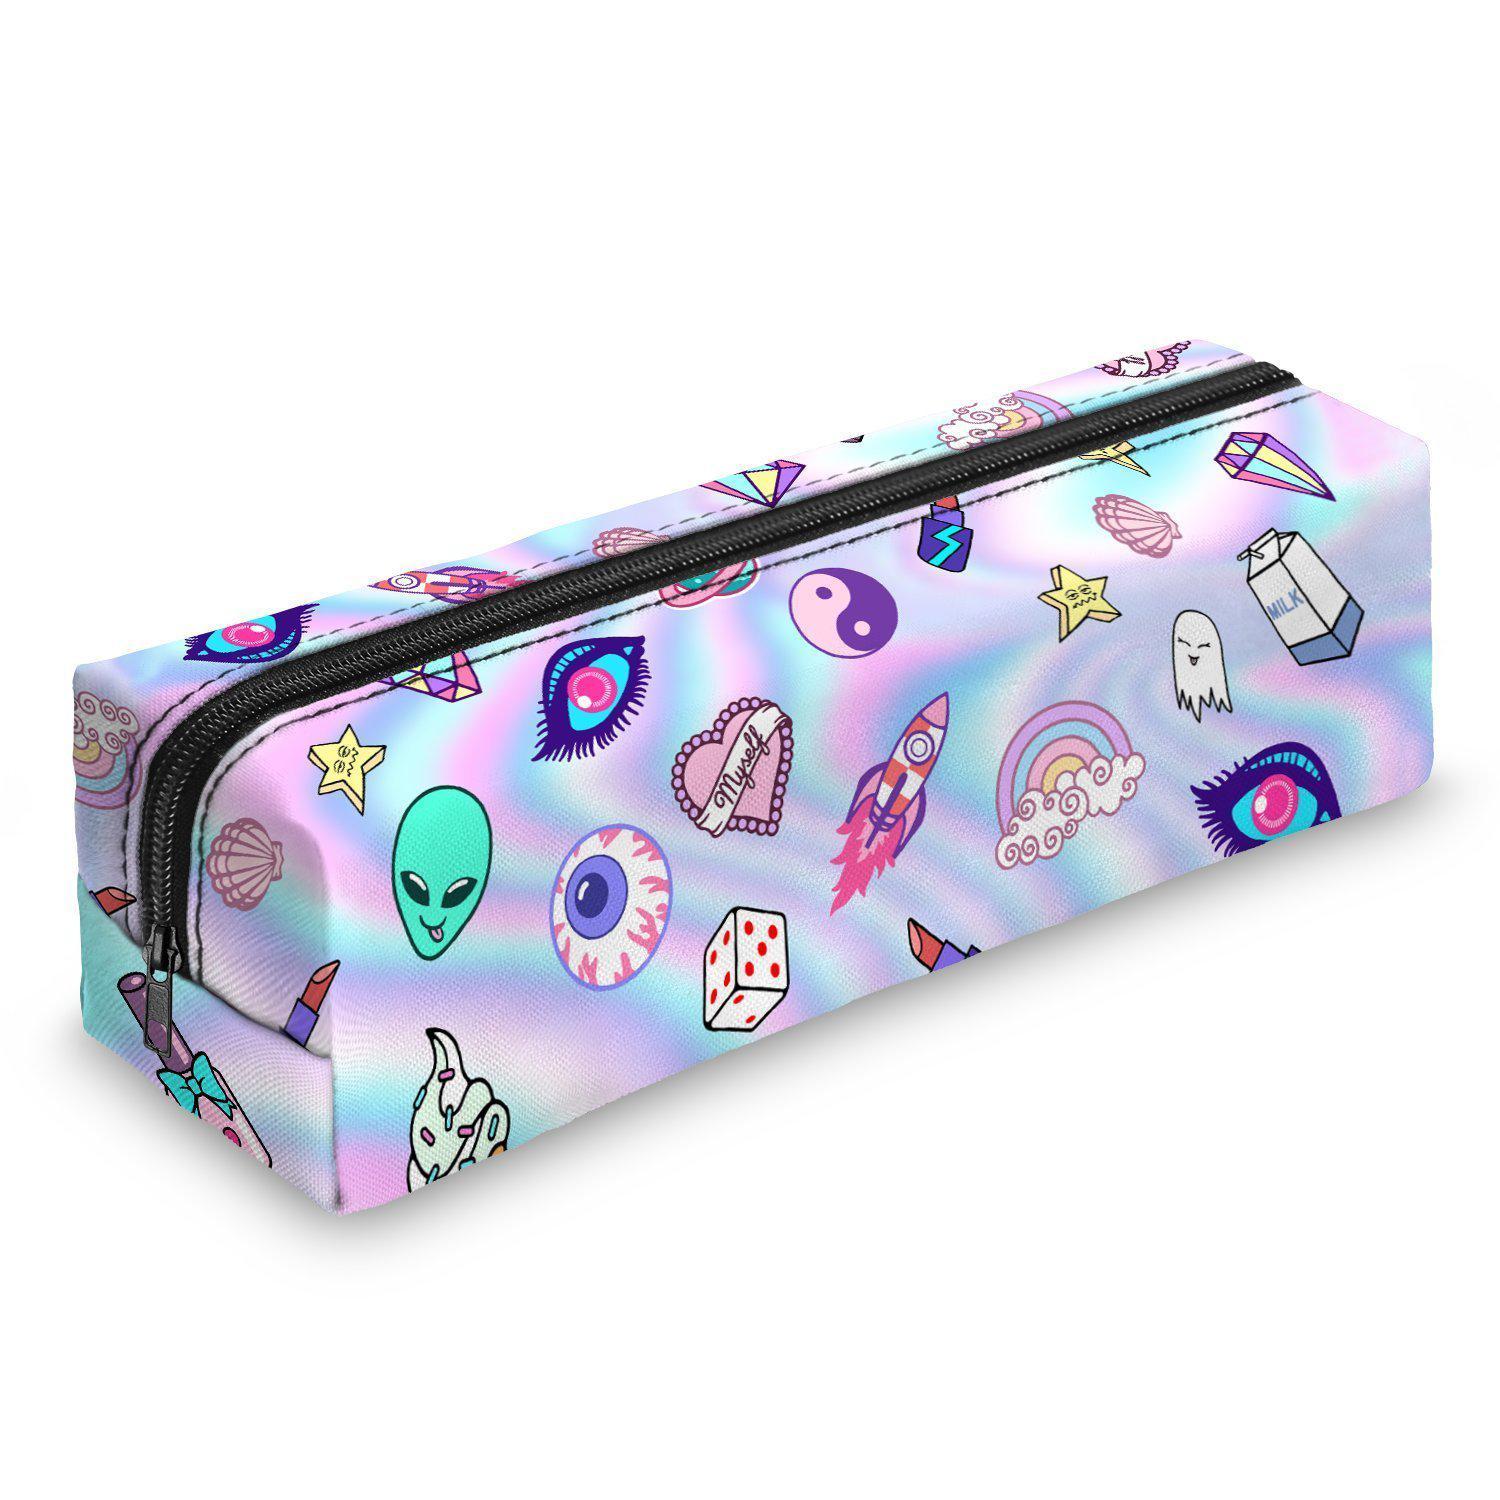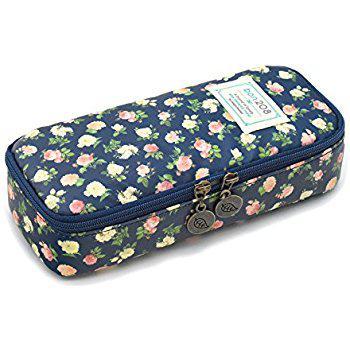The first image is the image on the left, the second image is the image on the right. Evaluate the accuracy of this statement regarding the images: "Four different variations of a pencil case, all of them closed, are depicted in one image.". Is it true? Answer yes or no. No. The first image is the image on the left, the second image is the image on the right. For the images shown, is this caption "Right and left images show the same number of pencil cases displayed in the same directional position." true? Answer yes or no. Yes. 